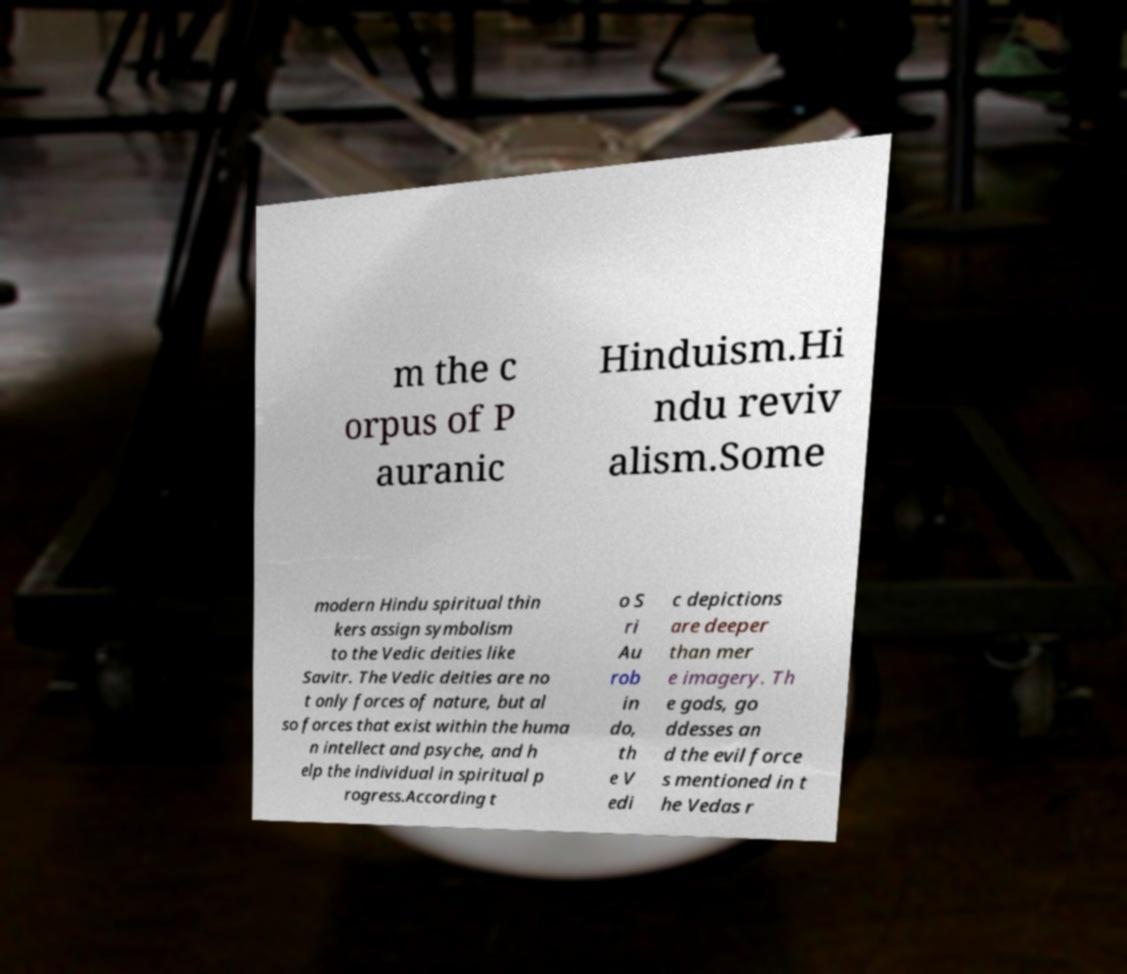Could you extract and type out the text from this image? m the c orpus of P auranic Hinduism.Hi ndu reviv alism.Some modern Hindu spiritual thin kers assign symbolism to the Vedic deities like Savitr. The Vedic deities are no t only forces of nature, but al so forces that exist within the huma n intellect and psyche, and h elp the individual in spiritual p rogress.According t o S ri Au rob in do, th e V edi c depictions are deeper than mer e imagery. Th e gods, go ddesses an d the evil force s mentioned in t he Vedas r 